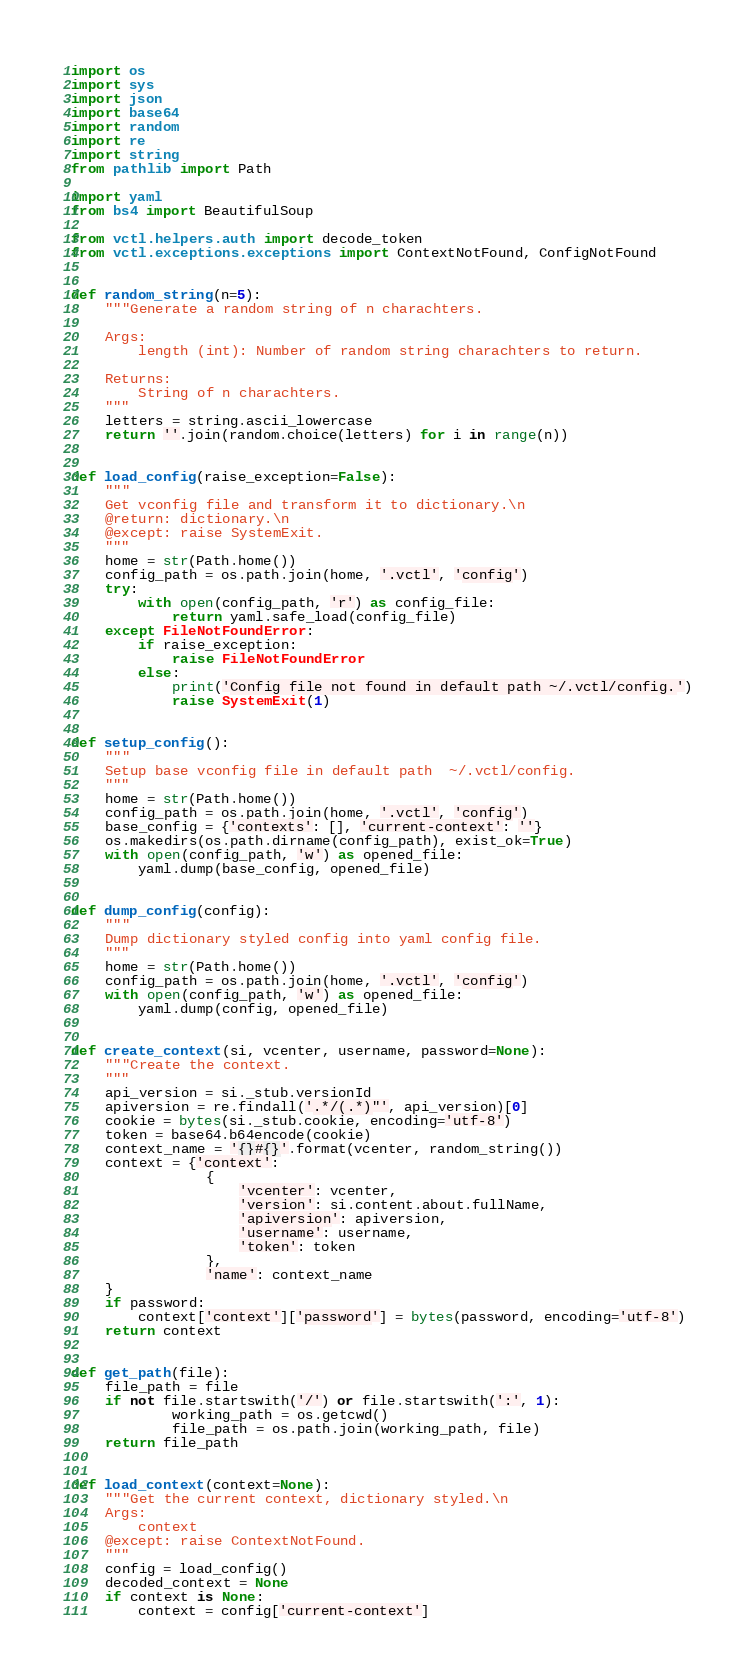Convert code to text. <code><loc_0><loc_0><loc_500><loc_500><_Python_>import os
import sys
import json
import base64
import random
import re
import string
from pathlib import Path

import yaml
from bs4 import BeautifulSoup

from vctl.helpers.auth import decode_token
from vctl.exceptions.exceptions import ContextNotFound, ConfigNotFound


def random_string(n=5):
    """Generate a random string of n charachters.

    Args:
        length (int): Number of random string charachters to return.

    Returns:
        String of n charachters.
    """
    letters = string.ascii_lowercase
    return ''.join(random.choice(letters) for i in range(n))


def load_config(raise_exception=False):
    """
    Get vconfig file and transform it to dictionary.\n
    @return: dictionary.\n
    @except: raise SystemExit.
    """
    home = str(Path.home())
    config_path = os.path.join(home, '.vctl', 'config')
    try:
        with open(config_path, 'r') as config_file:
            return yaml.safe_load(config_file)
    except FileNotFoundError:
        if raise_exception:
            raise FileNotFoundError
        else:
            print('Config file not found in default path ~/.vctl/config.')
            raise SystemExit(1)


def setup_config():
    """
    Setup base vconfig file in default path  ~/.vctl/config.
    """
    home = str(Path.home())
    config_path = os.path.join(home, '.vctl', 'config')
    base_config = {'contexts': [], 'current-context': ''}
    os.makedirs(os.path.dirname(config_path), exist_ok=True)
    with open(config_path, 'w') as opened_file:
        yaml.dump(base_config, opened_file)


def dump_config(config):
    """
    Dump dictionary styled config into yaml config file.
    """
    home = str(Path.home())
    config_path = os.path.join(home, '.vctl', 'config')
    with open(config_path, 'w') as opened_file:
        yaml.dump(config, opened_file)


def create_context(si, vcenter, username, password=None):
    """Create the context.
    """
    api_version = si._stub.versionId
    apiversion = re.findall('.*/(.*)"', api_version)[0]
    cookie = bytes(si._stub.cookie, encoding='utf-8')
    token = base64.b64encode(cookie)
    context_name = '{}#{}'.format(vcenter, random_string())
    context = {'context':
                {
                    'vcenter': vcenter,
                    'version': si.content.about.fullName,
                    'apiversion': apiversion,
                    'username': username,
                    'token': token
                },
                'name': context_name
    }
    if password:
        context['context']['password'] = bytes(password, encoding='utf-8')
    return context


def get_path(file):
    file_path = file
    if not file.startswith('/') or file.startswith(':', 1):
            working_path = os.getcwd()
            file_path = os.path.join(working_path, file)
    return file_path


def load_context(context=None):
    """Get the current context, dictionary styled.\n
    Args:
        context 
    @except: raise ContextNotFound.
    """
    config = load_config()
    decoded_context = None
    if context is None:
        context = config['current-context']</code> 